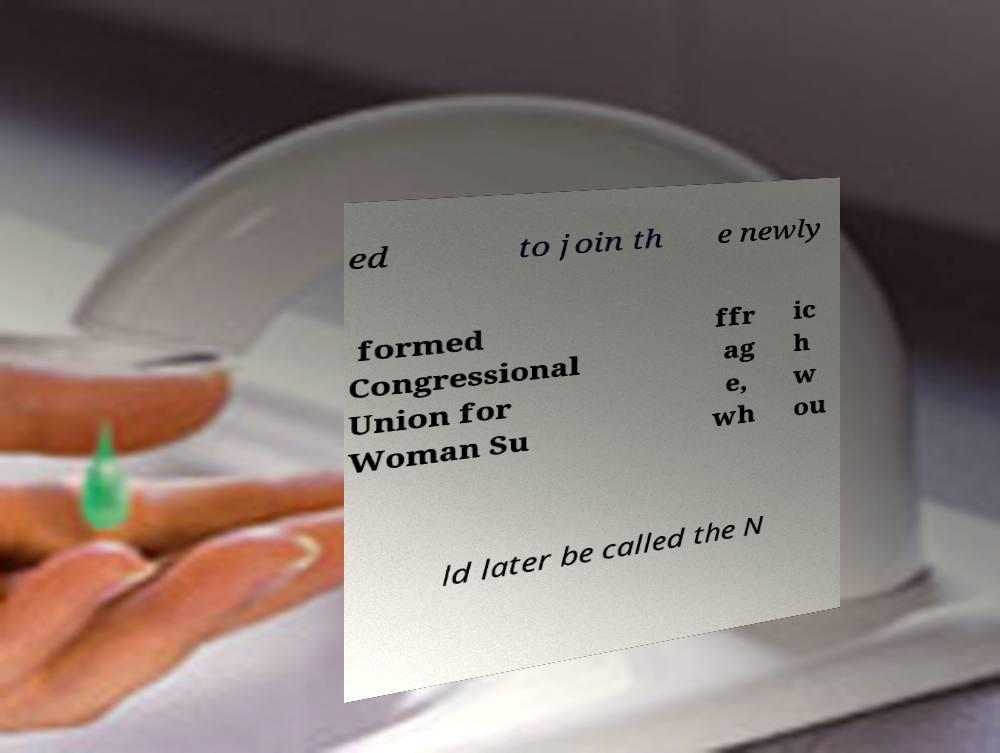I need the written content from this picture converted into text. Can you do that? ed to join th e newly formed Congressional Union for Woman Su ffr ag e, wh ic h w ou ld later be called the N 